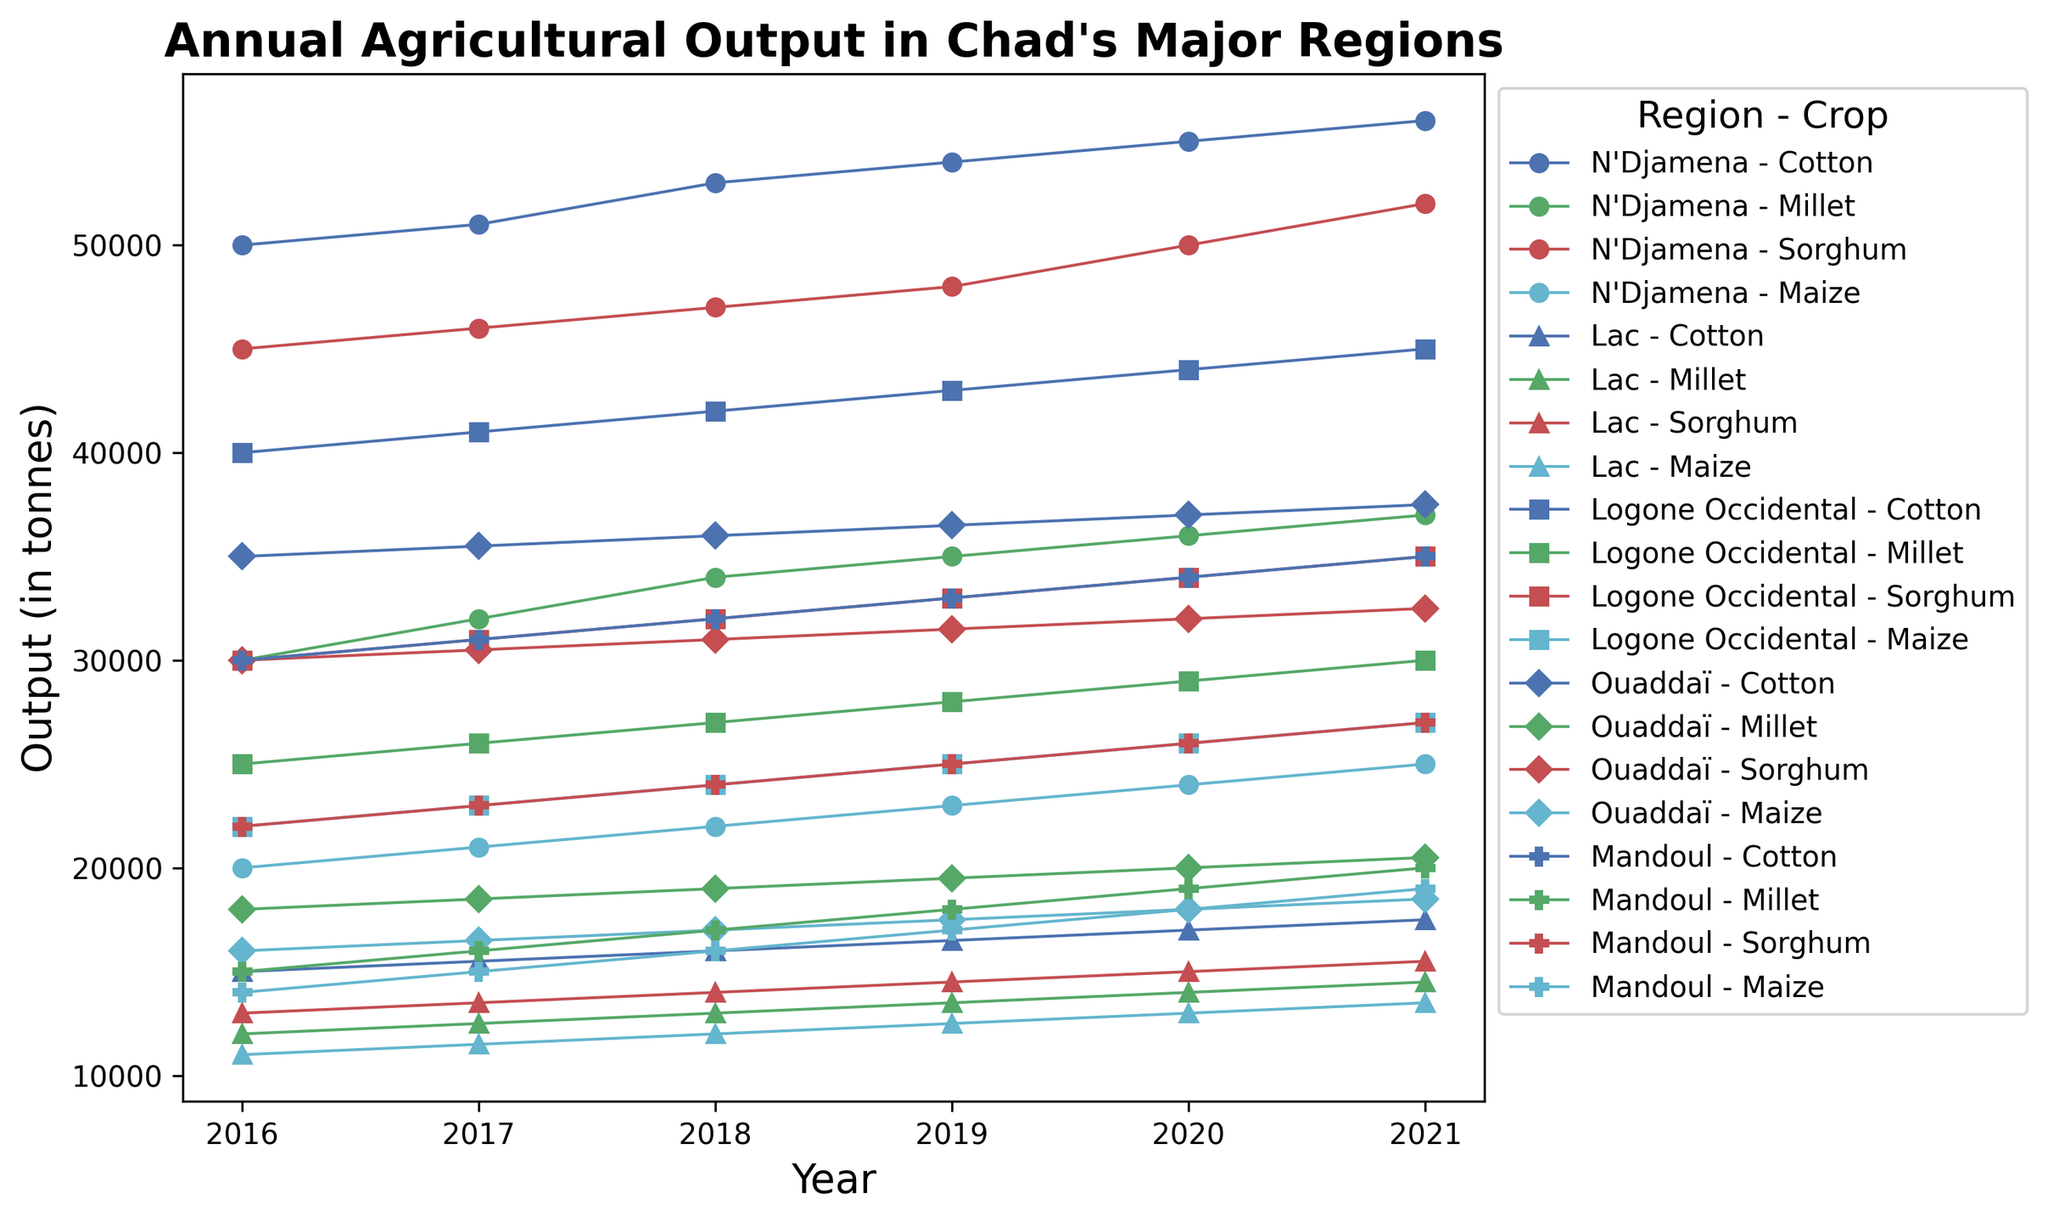What is the trend of maize production in N'Djamena from 2016 to 2021? The trend of maize production in N'Djamena shows a steady increase. Observing the plot, maize production values are 20000 in 2016, 21000 in 2017, 22000 in 2018, 23000 in 2019, 24000 in 2020, and 25000 in 2021.
Answer: Steady increase Which region had the highest millet production in 2021? Looking at the plot for 2021, N'Djamena has the highest millet production. It can be identified by the peak value among the plotted regions for millet that year.
Answer: N'Djamena In which year did Ouaddaï's sorghum production surpass Mandoul's for the first time? From the graph, comparing the plots for Ouaddaï and Mandoul, Ouaddaï's sorghum production surpasses Mandoul's from the year 2017 onwards.
Answer: 2017 How does the cotton production in Lac compare with Logone Occidental in 2020? By examining the graphs for 2020, Lac's cotton production is 17000, while Logone Occidental's is 44000, indicating Logone Occidental's cotton production is significantly higher.
Answer: Logone Occidental is higher What is the average maize production in Mandoul from 2016 to 2021? Adding Mandoul's maize production values (14000, 15000, 16000, 17000, 18000, 19000) and dividing by 6 gives us (14000 + 15000 + 16000 + 17000 + 18000 + 19000) / 6 = 16500.
Answer: 16500 Which crop showed the most consistent output increase across years in N'Djamena? From the plots, cotton in N'Djamena shows a consistent upward trajectory without any drops or constant values across the years.
Answer: Cotton Between 2019 and 2020, which region had the highest increase in millet production? Calculating the change in millet production between 2019 and 2020 for each region: N'Djamena (36000-35000=1000), Lac (14000-13500=500), Logone Occidental (29000-28000=1000), Ouaddaï (20000-19500=500), Mandoul (19000-18000=1000). Both N'Djamena, Logone Occidental, and Mandoul had a 1000 tonnes increase.
Answer: N'Djamena, Logone Occidental, Mandoul 